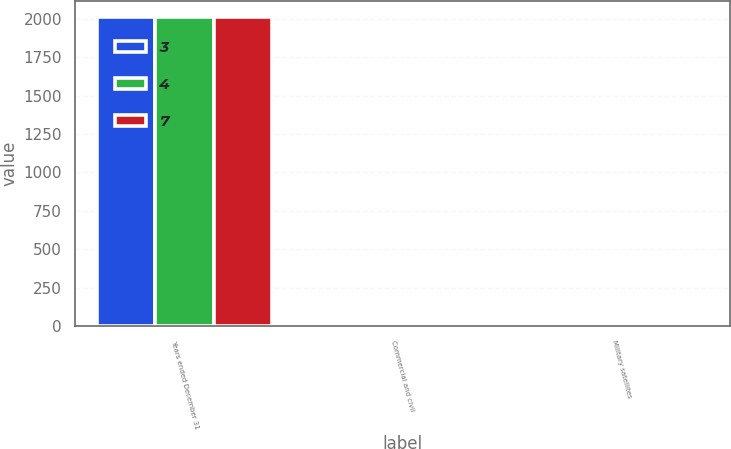Convert chart. <chart><loc_0><loc_0><loc_500><loc_500><stacked_bar_chart><ecel><fcel>Years ended December 31<fcel>Commercial and civil<fcel>Military satellites<nl><fcel>3<fcel>2013<fcel>3<fcel>4<nl><fcel>4<fcel>2012<fcel>3<fcel>7<nl><fcel>7<fcel>2011<fcel>1<fcel>3<nl></chart> 